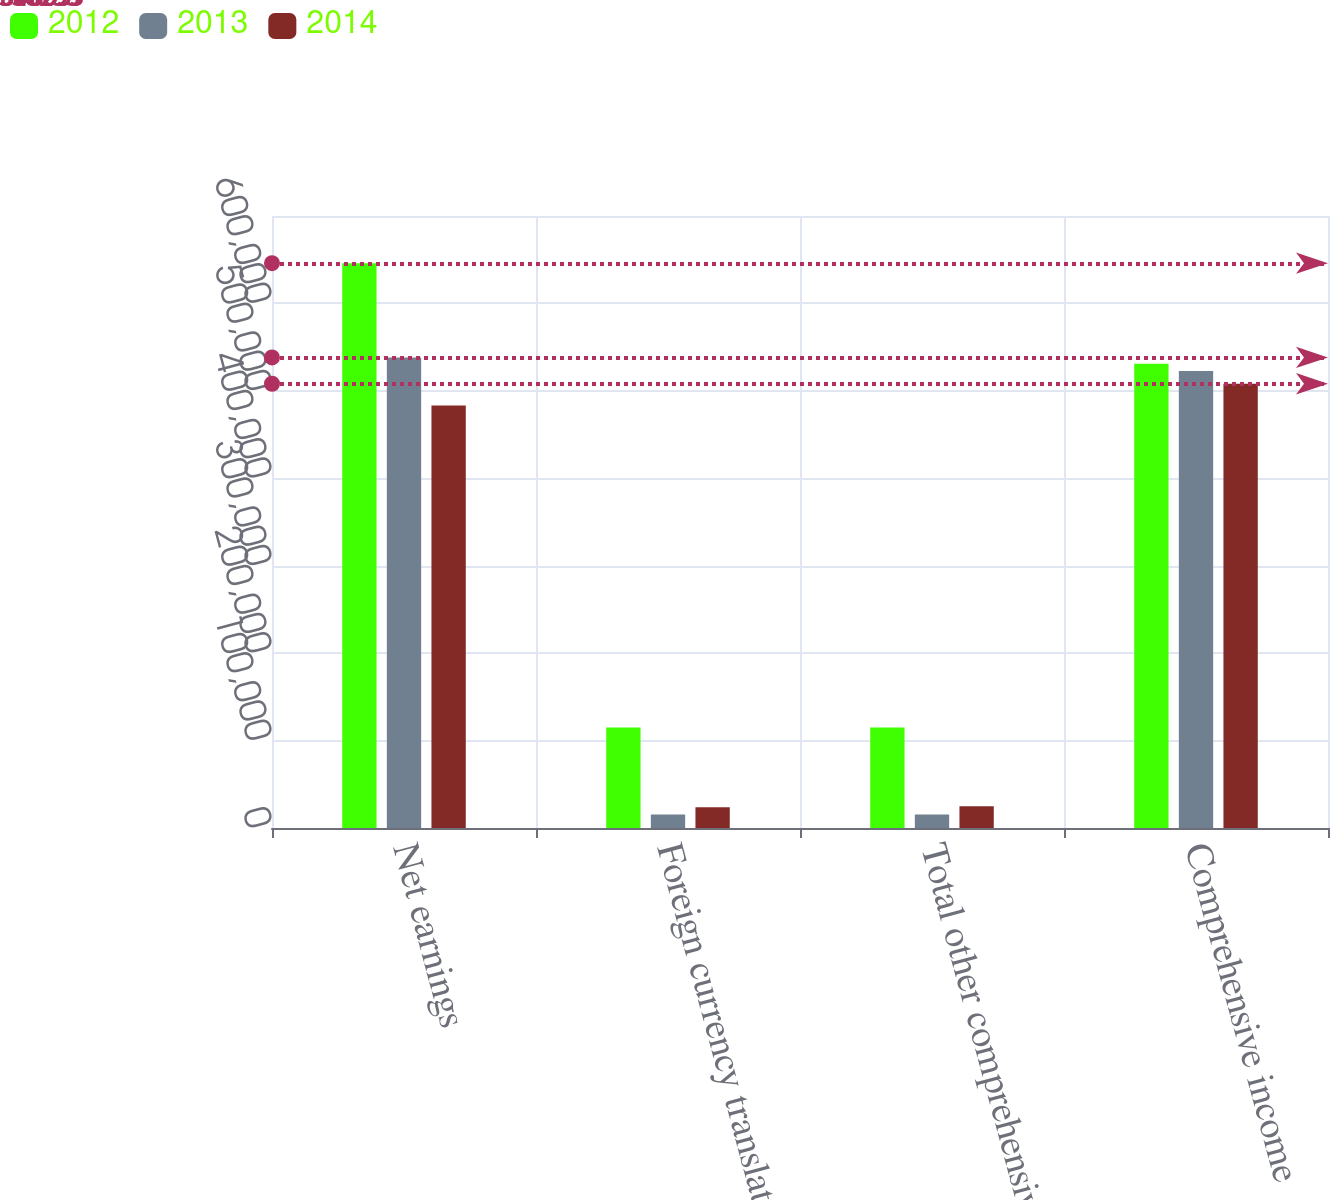Convert chart to OTSL. <chart><loc_0><loc_0><loc_500><loc_500><stacked_bar_chart><ecel><fcel>Net earnings<fcel>Foreign currency translation<fcel>Total other comprehensive<fcel>Comprehensive income<nl><fcel>2012<fcel>646033<fcel>115010<fcel>115010<fcel>531023<nl><fcel>2013<fcel>538293<fcel>15454<fcel>15454<fcel>522839<nl><fcel>2014<fcel>483360<fcel>23633<fcel>24737<fcel>508097<nl></chart> 